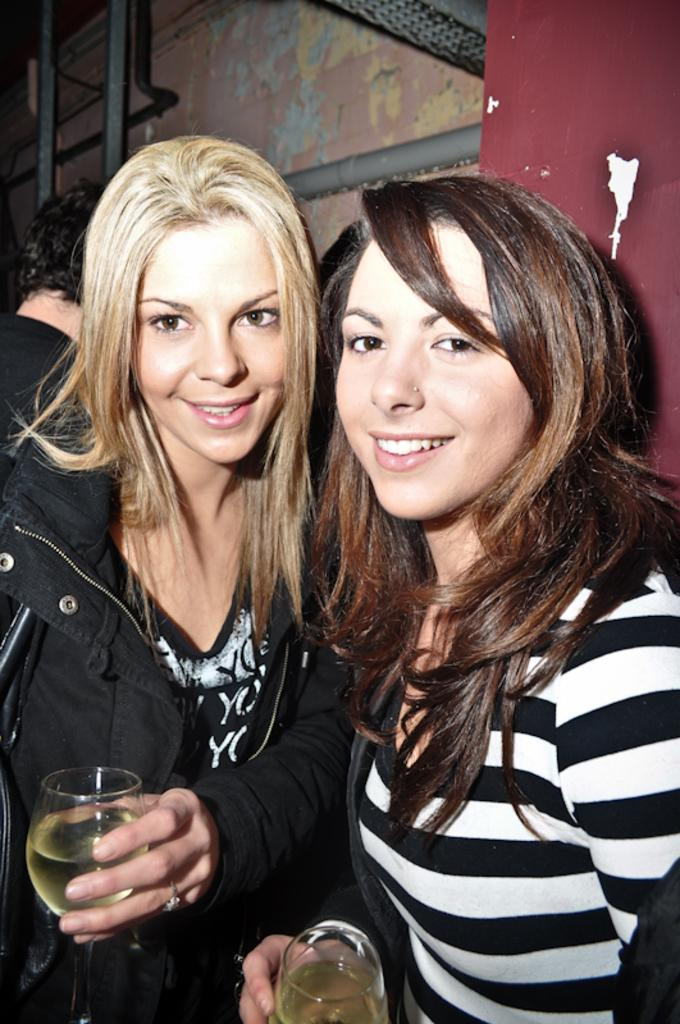How many people are in the image? There are two ladies in the image. What are the ladies doing in the image? The ladies are standing in the image. What are the ladies holding in their hands? The ladies are holding glasses in their hands. What can be seen in the background of the image? There is a wall in the background of the image. What type of competition are the ladies participating in, as seen in the image? There is no competition present in the image; it simply shows two ladies standing and holding glasses. Are the ladies sisters, as suggested by the image? The image does not provide any information about the relationship between the ladies, so we cannot determine if they are sisters. 